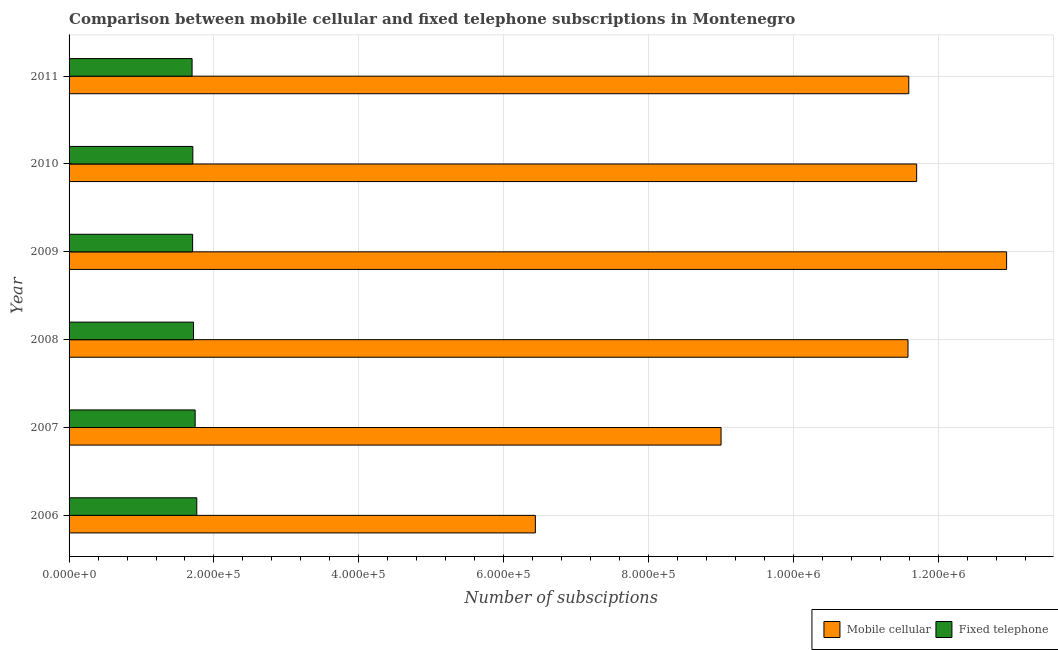How many groups of bars are there?
Provide a succinct answer. 6. Are the number of bars per tick equal to the number of legend labels?
Offer a very short reply. Yes. How many bars are there on the 2nd tick from the top?
Offer a very short reply. 2. How many bars are there on the 4th tick from the bottom?
Provide a succinct answer. 2. In how many cases, is the number of bars for a given year not equal to the number of legend labels?
Make the answer very short. 0. What is the number of mobile cellular subscriptions in 2009?
Offer a very short reply. 1.29e+06. Across all years, what is the maximum number of mobile cellular subscriptions?
Your answer should be very brief. 1.29e+06. Across all years, what is the minimum number of fixed telephone subscriptions?
Give a very brief answer. 1.70e+05. In which year was the number of mobile cellular subscriptions maximum?
Make the answer very short. 2009. What is the total number of mobile cellular subscriptions in the graph?
Make the answer very short. 6.32e+06. What is the difference between the number of mobile cellular subscriptions in 2006 and that in 2010?
Your answer should be very brief. -5.26e+05. What is the difference between the number of fixed telephone subscriptions in 2009 and the number of mobile cellular subscriptions in 2007?
Your answer should be compact. -7.29e+05. What is the average number of mobile cellular subscriptions per year?
Your answer should be compact. 1.05e+06. In the year 2010, what is the difference between the number of fixed telephone subscriptions and number of mobile cellular subscriptions?
Offer a terse response. -9.99e+05. What is the ratio of the number of mobile cellular subscriptions in 2010 to that in 2011?
Offer a terse response. 1.01. Is the number of mobile cellular subscriptions in 2007 less than that in 2009?
Offer a terse response. Yes. Is the difference between the number of mobile cellular subscriptions in 2010 and 2011 greater than the difference between the number of fixed telephone subscriptions in 2010 and 2011?
Provide a succinct answer. Yes. What is the difference between the highest and the second highest number of fixed telephone subscriptions?
Keep it short and to the point. 2243. What is the difference between the highest and the lowest number of fixed telephone subscriptions?
Your answer should be very brief. 6486. In how many years, is the number of mobile cellular subscriptions greater than the average number of mobile cellular subscriptions taken over all years?
Your answer should be very brief. 4. Is the sum of the number of mobile cellular subscriptions in 2008 and 2011 greater than the maximum number of fixed telephone subscriptions across all years?
Make the answer very short. Yes. What does the 2nd bar from the top in 2007 represents?
Your answer should be compact. Mobile cellular. What does the 1st bar from the bottom in 2008 represents?
Offer a terse response. Mobile cellular. How many bars are there?
Give a very brief answer. 12. Are all the bars in the graph horizontal?
Provide a succinct answer. Yes. How many years are there in the graph?
Your response must be concise. 6. What is the difference between two consecutive major ticks on the X-axis?
Your answer should be very brief. 2.00e+05. Does the graph contain any zero values?
Your response must be concise. No. Does the graph contain grids?
Ensure brevity in your answer.  Yes. What is the title of the graph?
Keep it short and to the point. Comparison between mobile cellular and fixed telephone subscriptions in Montenegro. Does "Pregnant women" appear as one of the legend labels in the graph?
Make the answer very short. No. What is the label or title of the X-axis?
Ensure brevity in your answer.  Number of subsciptions. What is the label or title of the Y-axis?
Your answer should be very brief. Year. What is the Number of subsciptions in Mobile cellular in 2006?
Keep it short and to the point. 6.44e+05. What is the Number of subsciptions in Fixed telephone in 2006?
Provide a succinct answer. 1.76e+05. What is the Number of subsciptions in Fixed telephone in 2007?
Offer a terse response. 1.74e+05. What is the Number of subsciptions in Mobile cellular in 2008?
Provide a succinct answer. 1.16e+06. What is the Number of subsciptions in Fixed telephone in 2008?
Provide a succinct answer. 1.72e+05. What is the Number of subsciptions in Mobile cellular in 2009?
Provide a short and direct response. 1.29e+06. What is the Number of subsciptions in Fixed telephone in 2009?
Your answer should be compact. 1.71e+05. What is the Number of subsciptions of Mobile cellular in 2010?
Your response must be concise. 1.17e+06. What is the Number of subsciptions in Fixed telephone in 2010?
Your answer should be very brief. 1.71e+05. What is the Number of subsciptions of Mobile cellular in 2011?
Offer a very short reply. 1.16e+06. What is the Number of subsciptions in Fixed telephone in 2011?
Keep it short and to the point. 1.70e+05. Across all years, what is the maximum Number of subsciptions in Mobile cellular?
Give a very brief answer. 1.29e+06. Across all years, what is the maximum Number of subsciptions in Fixed telephone?
Offer a very short reply. 1.76e+05. Across all years, what is the minimum Number of subsciptions in Mobile cellular?
Provide a succinct answer. 6.44e+05. Across all years, what is the minimum Number of subsciptions of Fixed telephone?
Keep it short and to the point. 1.70e+05. What is the total Number of subsciptions of Mobile cellular in the graph?
Your response must be concise. 6.32e+06. What is the total Number of subsciptions of Fixed telephone in the graph?
Offer a terse response. 1.03e+06. What is the difference between the Number of subsciptions in Mobile cellular in 2006 and that in 2007?
Offer a very short reply. -2.56e+05. What is the difference between the Number of subsciptions of Fixed telephone in 2006 and that in 2007?
Your answer should be very brief. 2243. What is the difference between the Number of subsciptions of Mobile cellular in 2006 and that in 2008?
Provide a short and direct response. -5.14e+05. What is the difference between the Number of subsciptions of Fixed telephone in 2006 and that in 2008?
Offer a very short reply. 4540. What is the difference between the Number of subsciptions of Mobile cellular in 2006 and that in 2009?
Keep it short and to the point. -6.50e+05. What is the difference between the Number of subsciptions of Fixed telephone in 2006 and that in 2009?
Offer a very short reply. 5736. What is the difference between the Number of subsciptions of Mobile cellular in 2006 and that in 2010?
Provide a short and direct response. -5.26e+05. What is the difference between the Number of subsciptions of Fixed telephone in 2006 and that in 2010?
Make the answer very short. 5433. What is the difference between the Number of subsciptions in Mobile cellular in 2006 and that in 2011?
Your response must be concise. -5.15e+05. What is the difference between the Number of subsciptions in Fixed telephone in 2006 and that in 2011?
Make the answer very short. 6486. What is the difference between the Number of subsciptions in Mobile cellular in 2007 and that in 2008?
Your response must be concise. -2.58e+05. What is the difference between the Number of subsciptions of Fixed telephone in 2007 and that in 2008?
Ensure brevity in your answer.  2297. What is the difference between the Number of subsciptions in Mobile cellular in 2007 and that in 2009?
Offer a terse response. -3.94e+05. What is the difference between the Number of subsciptions in Fixed telephone in 2007 and that in 2009?
Provide a succinct answer. 3493. What is the difference between the Number of subsciptions in Fixed telephone in 2007 and that in 2010?
Provide a short and direct response. 3190. What is the difference between the Number of subsciptions of Mobile cellular in 2007 and that in 2011?
Provide a short and direct response. -2.59e+05. What is the difference between the Number of subsciptions of Fixed telephone in 2007 and that in 2011?
Offer a terse response. 4243. What is the difference between the Number of subsciptions in Mobile cellular in 2008 and that in 2009?
Provide a succinct answer. -1.36e+05. What is the difference between the Number of subsciptions of Fixed telephone in 2008 and that in 2009?
Provide a succinct answer. 1196. What is the difference between the Number of subsciptions in Mobile cellular in 2008 and that in 2010?
Make the answer very short. -1.20e+04. What is the difference between the Number of subsciptions of Fixed telephone in 2008 and that in 2010?
Provide a short and direct response. 893. What is the difference between the Number of subsciptions of Mobile cellular in 2008 and that in 2011?
Provide a short and direct response. -1080. What is the difference between the Number of subsciptions in Fixed telephone in 2008 and that in 2011?
Offer a terse response. 1946. What is the difference between the Number of subsciptions of Mobile cellular in 2009 and that in 2010?
Make the answer very short. 1.24e+05. What is the difference between the Number of subsciptions of Fixed telephone in 2009 and that in 2010?
Your answer should be compact. -303. What is the difference between the Number of subsciptions in Mobile cellular in 2009 and that in 2011?
Offer a very short reply. 1.35e+05. What is the difference between the Number of subsciptions in Fixed telephone in 2009 and that in 2011?
Make the answer very short. 750. What is the difference between the Number of subsciptions of Mobile cellular in 2010 and that in 2011?
Ensure brevity in your answer.  1.09e+04. What is the difference between the Number of subsciptions of Fixed telephone in 2010 and that in 2011?
Your answer should be very brief. 1053. What is the difference between the Number of subsciptions in Mobile cellular in 2006 and the Number of subsciptions in Fixed telephone in 2007?
Offer a very short reply. 4.70e+05. What is the difference between the Number of subsciptions in Mobile cellular in 2006 and the Number of subsciptions in Fixed telephone in 2008?
Your answer should be very brief. 4.72e+05. What is the difference between the Number of subsciptions in Mobile cellular in 2006 and the Number of subsciptions in Fixed telephone in 2009?
Offer a very short reply. 4.73e+05. What is the difference between the Number of subsciptions of Mobile cellular in 2006 and the Number of subsciptions of Fixed telephone in 2010?
Offer a very short reply. 4.73e+05. What is the difference between the Number of subsciptions in Mobile cellular in 2006 and the Number of subsciptions in Fixed telephone in 2011?
Offer a terse response. 4.74e+05. What is the difference between the Number of subsciptions of Mobile cellular in 2007 and the Number of subsciptions of Fixed telephone in 2008?
Your answer should be compact. 7.28e+05. What is the difference between the Number of subsciptions of Mobile cellular in 2007 and the Number of subsciptions of Fixed telephone in 2009?
Your answer should be compact. 7.29e+05. What is the difference between the Number of subsciptions of Mobile cellular in 2007 and the Number of subsciptions of Fixed telephone in 2010?
Your answer should be compact. 7.29e+05. What is the difference between the Number of subsciptions of Mobile cellular in 2007 and the Number of subsciptions of Fixed telephone in 2011?
Make the answer very short. 7.30e+05. What is the difference between the Number of subsciptions in Mobile cellular in 2008 and the Number of subsciptions in Fixed telephone in 2009?
Provide a succinct answer. 9.87e+05. What is the difference between the Number of subsciptions in Mobile cellular in 2008 and the Number of subsciptions in Fixed telephone in 2010?
Your response must be concise. 9.87e+05. What is the difference between the Number of subsciptions of Mobile cellular in 2008 and the Number of subsciptions of Fixed telephone in 2011?
Provide a short and direct response. 9.88e+05. What is the difference between the Number of subsciptions of Mobile cellular in 2009 and the Number of subsciptions of Fixed telephone in 2010?
Offer a very short reply. 1.12e+06. What is the difference between the Number of subsciptions in Mobile cellular in 2009 and the Number of subsciptions in Fixed telephone in 2011?
Give a very brief answer. 1.12e+06. What is the difference between the Number of subsciptions in Mobile cellular in 2010 and the Number of subsciptions in Fixed telephone in 2011?
Keep it short and to the point. 1.00e+06. What is the average Number of subsciptions of Mobile cellular per year?
Your answer should be compact. 1.05e+06. What is the average Number of subsciptions in Fixed telephone per year?
Your response must be concise. 1.72e+05. In the year 2006, what is the difference between the Number of subsciptions in Mobile cellular and Number of subsciptions in Fixed telephone?
Your answer should be very brief. 4.67e+05. In the year 2007, what is the difference between the Number of subsciptions of Mobile cellular and Number of subsciptions of Fixed telephone?
Ensure brevity in your answer.  7.26e+05. In the year 2008, what is the difference between the Number of subsciptions of Mobile cellular and Number of subsciptions of Fixed telephone?
Make the answer very short. 9.86e+05. In the year 2009, what is the difference between the Number of subsciptions of Mobile cellular and Number of subsciptions of Fixed telephone?
Your response must be concise. 1.12e+06. In the year 2010, what is the difference between the Number of subsciptions in Mobile cellular and Number of subsciptions in Fixed telephone?
Offer a terse response. 9.99e+05. In the year 2011, what is the difference between the Number of subsciptions in Mobile cellular and Number of subsciptions in Fixed telephone?
Your answer should be compact. 9.89e+05. What is the ratio of the Number of subsciptions in Mobile cellular in 2006 to that in 2007?
Offer a very short reply. 0.72. What is the ratio of the Number of subsciptions of Fixed telephone in 2006 to that in 2007?
Keep it short and to the point. 1.01. What is the ratio of the Number of subsciptions in Mobile cellular in 2006 to that in 2008?
Provide a short and direct response. 0.56. What is the ratio of the Number of subsciptions in Fixed telephone in 2006 to that in 2008?
Your answer should be compact. 1.03. What is the ratio of the Number of subsciptions of Mobile cellular in 2006 to that in 2009?
Keep it short and to the point. 0.5. What is the ratio of the Number of subsciptions in Fixed telephone in 2006 to that in 2009?
Your answer should be compact. 1.03. What is the ratio of the Number of subsciptions of Mobile cellular in 2006 to that in 2010?
Provide a short and direct response. 0.55. What is the ratio of the Number of subsciptions in Fixed telephone in 2006 to that in 2010?
Provide a short and direct response. 1.03. What is the ratio of the Number of subsciptions in Mobile cellular in 2006 to that in 2011?
Give a very brief answer. 0.56. What is the ratio of the Number of subsciptions in Fixed telephone in 2006 to that in 2011?
Offer a terse response. 1.04. What is the ratio of the Number of subsciptions in Mobile cellular in 2007 to that in 2008?
Offer a terse response. 0.78. What is the ratio of the Number of subsciptions of Fixed telephone in 2007 to that in 2008?
Make the answer very short. 1.01. What is the ratio of the Number of subsciptions of Mobile cellular in 2007 to that in 2009?
Offer a very short reply. 0.7. What is the ratio of the Number of subsciptions of Fixed telephone in 2007 to that in 2009?
Offer a terse response. 1.02. What is the ratio of the Number of subsciptions in Mobile cellular in 2007 to that in 2010?
Your answer should be compact. 0.77. What is the ratio of the Number of subsciptions in Fixed telephone in 2007 to that in 2010?
Ensure brevity in your answer.  1.02. What is the ratio of the Number of subsciptions in Mobile cellular in 2007 to that in 2011?
Provide a succinct answer. 0.78. What is the ratio of the Number of subsciptions of Fixed telephone in 2007 to that in 2011?
Ensure brevity in your answer.  1.02. What is the ratio of the Number of subsciptions in Mobile cellular in 2008 to that in 2009?
Your answer should be compact. 0.89. What is the ratio of the Number of subsciptions in Fixed telephone in 2008 to that in 2009?
Your response must be concise. 1.01. What is the ratio of the Number of subsciptions in Mobile cellular in 2008 to that in 2010?
Offer a terse response. 0.99. What is the ratio of the Number of subsciptions in Fixed telephone in 2008 to that in 2011?
Offer a very short reply. 1.01. What is the ratio of the Number of subsciptions in Mobile cellular in 2009 to that in 2010?
Keep it short and to the point. 1.11. What is the ratio of the Number of subsciptions of Mobile cellular in 2009 to that in 2011?
Make the answer very short. 1.12. What is the ratio of the Number of subsciptions of Mobile cellular in 2010 to that in 2011?
Provide a short and direct response. 1.01. What is the difference between the highest and the second highest Number of subsciptions in Mobile cellular?
Provide a succinct answer. 1.24e+05. What is the difference between the highest and the second highest Number of subsciptions of Fixed telephone?
Your answer should be compact. 2243. What is the difference between the highest and the lowest Number of subsciptions in Mobile cellular?
Keep it short and to the point. 6.50e+05. What is the difference between the highest and the lowest Number of subsciptions of Fixed telephone?
Provide a succinct answer. 6486. 